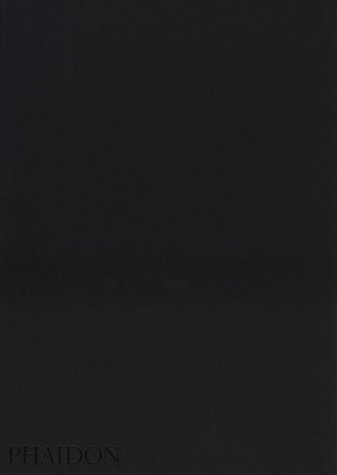How does Larry Towell's artistic style contribute to the narrative of the book? Larry Towell's artistic style, featuring intimate, candid, and often stark black and white images, effectively captures the essence of the Mennonite community, highlighting both the austerity and the beauty of their way of life. 